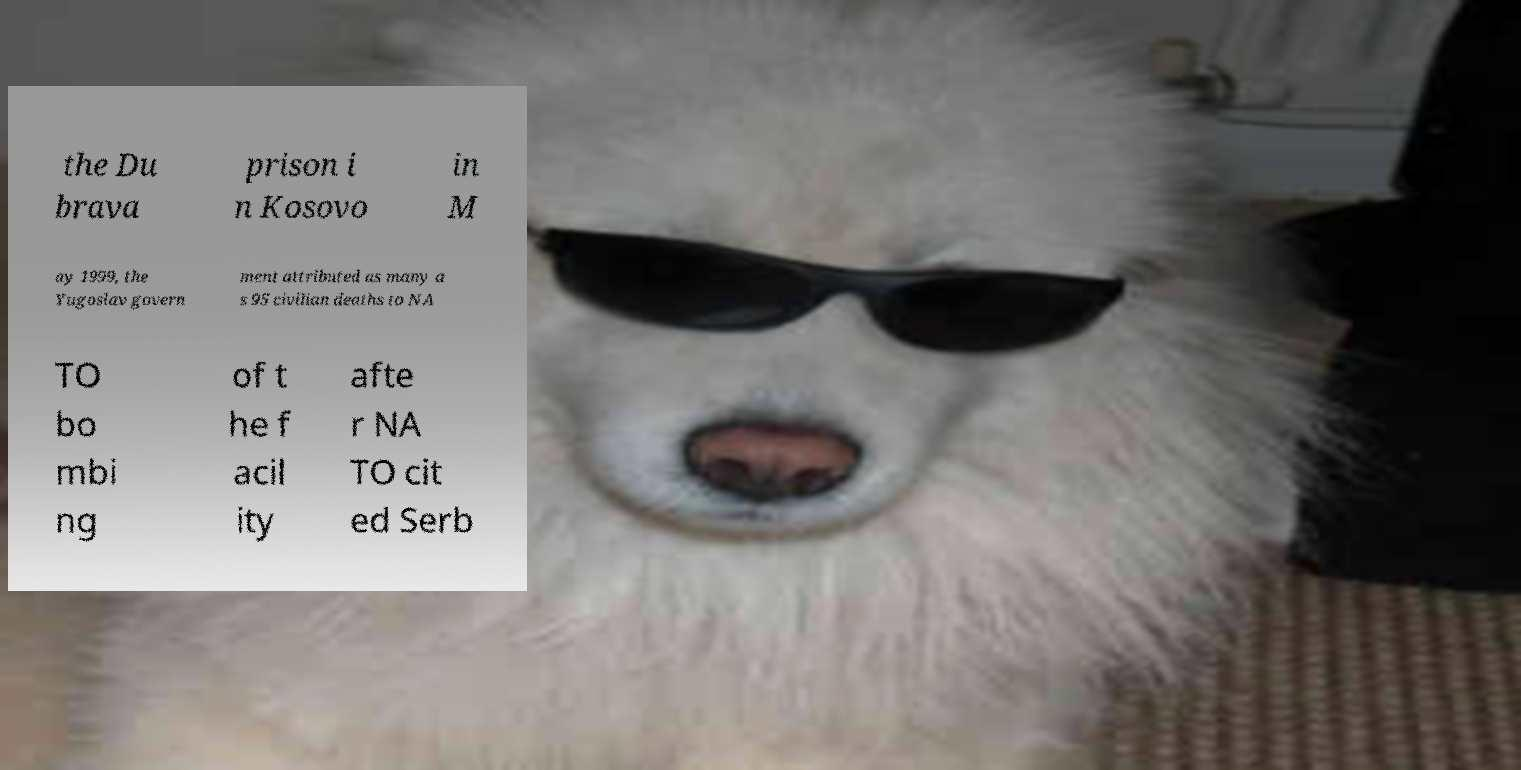Can you read and provide the text displayed in the image?This photo seems to have some interesting text. Can you extract and type it out for me? the Du brava prison i n Kosovo in M ay 1999, the Yugoslav govern ment attributed as many a s 95 civilian deaths to NA TO bo mbi ng of t he f acil ity afte r NA TO cit ed Serb 